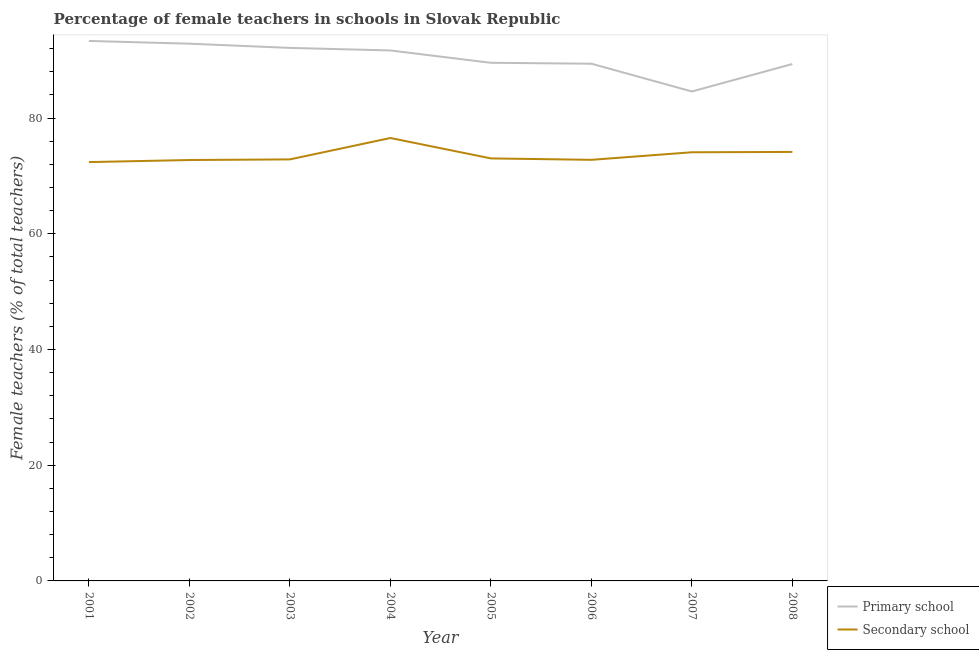Is the number of lines equal to the number of legend labels?
Keep it short and to the point. Yes. What is the percentage of female teachers in primary schools in 2007?
Your response must be concise. 84.6. Across all years, what is the maximum percentage of female teachers in primary schools?
Your response must be concise. 93.33. Across all years, what is the minimum percentage of female teachers in secondary schools?
Make the answer very short. 72.39. In which year was the percentage of female teachers in secondary schools maximum?
Give a very brief answer. 2004. What is the total percentage of female teachers in secondary schools in the graph?
Your response must be concise. 588.6. What is the difference between the percentage of female teachers in primary schools in 2004 and that in 2008?
Give a very brief answer. 2.34. What is the difference between the percentage of female teachers in secondary schools in 2002 and the percentage of female teachers in primary schools in 2003?
Provide a short and direct response. -19.38. What is the average percentage of female teachers in primary schools per year?
Ensure brevity in your answer.  90.36. In the year 2006, what is the difference between the percentage of female teachers in secondary schools and percentage of female teachers in primary schools?
Your answer should be compact. -16.61. What is the ratio of the percentage of female teachers in primary schools in 2007 to that in 2008?
Provide a succinct answer. 0.95. Is the percentage of female teachers in secondary schools in 2005 less than that in 2007?
Ensure brevity in your answer.  Yes. What is the difference between the highest and the second highest percentage of female teachers in primary schools?
Make the answer very short. 0.48. What is the difference between the highest and the lowest percentage of female teachers in primary schools?
Your response must be concise. 8.74. Is the sum of the percentage of female teachers in secondary schools in 2006 and 2007 greater than the maximum percentage of female teachers in primary schools across all years?
Offer a terse response. Yes. Does the percentage of female teachers in secondary schools monotonically increase over the years?
Give a very brief answer. No. Is the percentage of female teachers in secondary schools strictly greater than the percentage of female teachers in primary schools over the years?
Provide a short and direct response. No. How many lines are there?
Keep it short and to the point. 2. What is the difference between two consecutive major ticks on the Y-axis?
Offer a terse response. 20. Does the graph contain any zero values?
Provide a succinct answer. No. Where does the legend appear in the graph?
Offer a very short reply. Bottom right. How many legend labels are there?
Your answer should be compact. 2. What is the title of the graph?
Ensure brevity in your answer.  Percentage of female teachers in schools in Slovak Republic. Does "IMF nonconcessional" appear as one of the legend labels in the graph?
Your response must be concise. No. What is the label or title of the X-axis?
Keep it short and to the point. Year. What is the label or title of the Y-axis?
Ensure brevity in your answer.  Female teachers (% of total teachers). What is the Female teachers (% of total teachers) in Primary school in 2001?
Give a very brief answer. 93.33. What is the Female teachers (% of total teachers) of Secondary school in 2001?
Offer a very short reply. 72.39. What is the Female teachers (% of total teachers) in Primary school in 2002?
Your answer should be very brief. 92.85. What is the Female teachers (% of total teachers) of Secondary school in 2002?
Your answer should be compact. 72.75. What is the Female teachers (% of total teachers) in Primary school in 2003?
Ensure brevity in your answer.  92.13. What is the Female teachers (% of total teachers) of Secondary school in 2003?
Give a very brief answer. 72.86. What is the Female teachers (% of total teachers) of Primary school in 2004?
Provide a succinct answer. 91.69. What is the Female teachers (% of total teachers) of Secondary school in 2004?
Your answer should be compact. 76.55. What is the Female teachers (% of total teachers) in Primary school in 2005?
Provide a short and direct response. 89.55. What is the Female teachers (% of total teachers) of Secondary school in 2005?
Offer a terse response. 73.03. What is the Female teachers (% of total teachers) of Primary school in 2006?
Your response must be concise. 89.4. What is the Female teachers (% of total teachers) in Secondary school in 2006?
Ensure brevity in your answer.  72.78. What is the Female teachers (% of total teachers) of Primary school in 2007?
Provide a short and direct response. 84.6. What is the Female teachers (% of total teachers) of Secondary school in 2007?
Give a very brief answer. 74.09. What is the Female teachers (% of total teachers) of Primary school in 2008?
Offer a terse response. 89.34. What is the Female teachers (% of total teachers) in Secondary school in 2008?
Give a very brief answer. 74.15. Across all years, what is the maximum Female teachers (% of total teachers) in Primary school?
Offer a very short reply. 93.33. Across all years, what is the maximum Female teachers (% of total teachers) of Secondary school?
Provide a short and direct response. 76.55. Across all years, what is the minimum Female teachers (% of total teachers) in Primary school?
Provide a short and direct response. 84.6. Across all years, what is the minimum Female teachers (% of total teachers) of Secondary school?
Provide a short and direct response. 72.39. What is the total Female teachers (% of total teachers) in Primary school in the graph?
Ensure brevity in your answer.  722.88. What is the total Female teachers (% of total teachers) in Secondary school in the graph?
Provide a succinct answer. 588.6. What is the difference between the Female teachers (% of total teachers) of Primary school in 2001 and that in 2002?
Offer a very short reply. 0.48. What is the difference between the Female teachers (% of total teachers) in Secondary school in 2001 and that in 2002?
Ensure brevity in your answer.  -0.36. What is the difference between the Female teachers (% of total teachers) in Primary school in 2001 and that in 2003?
Your answer should be compact. 1.21. What is the difference between the Female teachers (% of total teachers) of Secondary school in 2001 and that in 2003?
Keep it short and to the point. -0.47. What is the difference between the Female teachers (% of total teachers) of Primary school in 2001 and that in 2004?
Offer a very short reply. 1.65. What is the difference between the Female teachers (% of total teachers) of Secondary school in 2001 and that in 2004?
Offer a very short reply. -4.16. What is the difference between the Female teachers (% of total teachers) in Primary school in 2001 and that in 2005?
Keep it short and to the point. 3.78. What is the difference between the Female teachers (% of total teachers) of Secondary school in 2001 and that in 2005?
Your response must be concise. -0.64. What is the difference between the Female teachers (% of total teachers) in Primary school in 2001 and that in 2006?
Provide a short and direct response. 3.93. What is the difference between the Female teachers (% of total teachers) of Secondary school in 2001 and that in 2006?
Ensure brevity in your answer.  -0.39. What is the difference between the Female teachers (% of total teachers) of Primary school in 2001 and that in 2007?
Keep it short and to the point. 8.74. What is the difference between the Female teachers (% of total teachers) in Secondary school in 2001 and that in 2007?
Keep it short and to the point. -1.7. What is the difference between the Female teachers (% of total teachers) of Primary school in 2001 and that in 2008?
Offer a terse response. 3.99. What is the difference between the Female teachers (% of total teachers) in Secondary school in 2001 and that in 2008?
Give a very brief answer. -1.76. What is the difference between the Female teachers (% of total teachers) of Primary school in 2002 and that in 2003?
Ensure brevity in your answer.  0.73. What is the difference between the Female teachers (% of total teachers) in Secondary school in 2002 and that in 2003?
Provide a succinct answer. -0.11. What is the difference between the Female teachers (% of total teachers) of Primary school in 2002 and that in 2004?
Provide a succinct answer. 1.17. What is the difference between the Female teachers (% of total teachers) of Secondary school in 2002 and that in 2004?
Your answer should be very brief. -3.8. What is the difference between the Female teachers (% of total teachers) in Primary school in 2002 and that in 2005?
Keep it short and to the point. 3.3. What is the difference between the Female teachers (% of total teachers) in Secondary school in 2002 and that in 2005?
Give a very brief answer. -0.28. What is the difference between the Female teachers (% of total teachers) in Primary school in 2002 and that in 2006?
Make the answer very short. 3.46. What is the difference between the Female teachers (% of total teachers) of Secondary school in 2002 and that in 2006?
Provide a short and direct response. -0.03. What is the difference between the Female teachers (% of total teachers) in Primary school in 2002 and that in 2007?
Give a very brief answer. 8.26. What is the difference between the Female teachers (% of total teachers) in Secondary school in 2002 and that in 2007?
Offer a terse response. -1.34. What is the difference between the Female teachers (% of total teachers) in Primary school in 2002 and that in 2008?
Ensure brevity in your answer.  3.51. What is the difference between the Female teachers (% of total teachers) of Secondary school in 2002 and that in 2008?
Offer a very short reply. -1.4. What is the difference between the Female teachers (% of total teachers) in Primary school in 2003 and that in 2004?
Your answer should be compact. 0.44. What is the difference between the Female teachers (% of total teachers) of Secondary school in 2003 and that in 2004?
Make the answer very short. -3.7. What is the difference between the Female teachers (% of total teachers) of Primary school in 2003 and that in 2005?
Your answer should be very brief. 2.57. What is the difference between the Female teachers (% of total teachers) in Secondary school in 2003 and that in 2005?
Offer a very short reply. -0.17. What is the difference between the Female teachers (% of total teachers) of Primary school in 2003 and that in 2006?
Provide a short and direct response. 2.73. What is the difference between the Female teachers (% of total teachers) of Secondary school in 2003 and that in 2006?
Provide a short and direct response. 0.07. What is the difference between the Female teachers (% of total teachers) in Primary school in 2003 and that in 2007?
Keep it short and to the point. 7.53. What is the difference between the Female teachers (% of total teachers) of Secondary school in 2003 and that in 2007?
Offer a terse response. -1.23. What is the difference between the Female teachers (% of total teachers) in Primary school in 2003 and that in 2008?
Offer a very short reply. 2.78. What is the difference between the Female teachers (% of total teachers) of Secondary school in 2003 and that in 2008?
Make the answer very short. -1.29. What is the difference between the Female teachers (% of total teachers) of Primary school in 2004 and that in 2005?
Keep it short and to the point. 2.13. What is the difference between the Female teachers (% of total teachers) in Secondary school in 2004 and that in 2005?
Provide a succinct answer. 3.53. What is the difference between the Female teachers (% of total teachers) of Primary school in 2004 and that in 2006?
Your response must be concise. 2.29. What is the difference between the Female teachers (% of total teachers) in Secondary school in 2004 and that in 2006?
Keep it short and to the point. 3.77. What is the difference between the Female teachers (% of total teachers) of Primary school in 2004 and that in 2007?
Give a very brief answer. 7.09. What is the difference between the Female teachers (% of total teachers) in Secondary school in 2004 and that in 2007?
Provide a short and direct response. 2.46. What is the difference between the Female teachers (% of total teachers) in Primary school in 2004 and that in 2008?
Your answer should be very brief. 2.34. What is the difference between the Female teachers (% of total teachers) in Secondary school in 2004 and that in 2008?
Offer a terse response. 2.41. What is the difference between the Female teachers (% of total teachers) of Primary school in 2005 and that in 2006?
Give a very brief answer. 0.16. What is the difference between the Female teachers (% of total teachers) in Secondary school in 2005 and that in 2006?
Keep it short and to the point. 0.25. What is the difference between the Female teachers (% of total teachers) of Primary school in 2005 and that in 2007?
Provide a succinct answer. 4.96. What is the difference between the Female teachers (% of total teachers) in Secondary school in 2005 and that in 2007?
Provide a short and direct response. -1.06. What is the difference between the Female teachers (% of total teachers) of Primary school in 2005 and that in 2008?
Offer a terse response. 0.21. What is the difference between the Female teachers (% of total teachers) in Secondary school in 2005 and that in 2008?
Give a very brief answer. -1.12. What is the difference between the Female teachers (% of total teachers) of Primary school in 2006 and that in 2007?
Provide a short and direct response. 4.8. What is the difference between the Female teachers (% of total teachers) in Secondary school in 2006 and that in 2007?
Provide a short and direct response. -1.31. What is the difference between the Female teachers (% of total teachers) of Primary school in 2006 and that in 2008?
Your answer should be compact. 0.06. What is the difference between the Female teachers (% of total teachers) in Secondary school in 2006 and that in 2008?
Offer a very short reply. -1.37. What is the difference between the Female teachers (% of total teachers) in Primary school in 2007 and that in 2008?
Give a very brief answer. -4.75. What is the difference between the Female teachers (% of total teachers) in Secondary school in 2007 and that in 2008?
Offer a very short reply. -0.06. What is the difference between the Female teachers (% of total teachers) in Primary school in 2001 and the Female teachers (% of total teachers) in Secondary school in 2002?
Offer a terse response. 20.58. What is the difference between the Female teachers (% of total teachers) in Primary school in 2001 and the Female teachers (% of total teachers) in Secondary school in 2003?
Ensure brevity in your answer.  20.47. What is the difference between the Female teachers (% of total teachers) in Primary school in 2001 and the Female teachers (% of total teachers) in Secondary school in 2004?
Keep it short and to the point. 16.78. What is the difference between the Female teachers (% of total teachers) of Primary school in 2001 and the Female teachers (% of total teachers) of Secondary school in 2005?
Your answer should be very brief. 20.3. What is the difference between the Female teachers (% of total teachers) in Primary school in 2001 and the Female teachers (% of total teachers) in Secondary school in 2006?
Your answer should be very brief. 20.55. What is the difference between the Female teachers (% of total teachers) of Primary school in 2001 and the Female teachers (% of total teachers) of Secondary school in 2007?
Make the answer very short. 19.24. What is the difference between the Female teachers (% of total teachers) in Primary school in 2001 and the Female teachers (% of total teachers) in Secondary school in 2008?
Offer a terse response. 19.18. What is the difference between the Female teachers (% of total teachers) in Primary school in 2002 and the Female teachers (% of total teachers) in Secondary school in 2003?
Offer a very short reply. 20. What is the difference between the Female teachers (% of total teachers) of Primary school in 2002 and the Female teachers (% of total teachers) of Secondary school in 2004?
Provide a succinct answer. 16.3. What is the difference between the Female teachers (% of total teachers) in Primary school in 2002 and the Female teachers (% of total teachers) in Secondary school in 2005?
Provide a short and direct response. 19.83. What is the difference between the Female teachers (% of total teachers) in Primary school in 2002 and the Female teachers (% of total teachers) in Secondary school in 2006?
Your answer should be compact. 20.07. What is the difference between the Female teachers (% of total teachers) of Primary school in 2002 and the Female teachers (% of total teachers) of Secondary school in 2007?
Make the answer very short. 18.77. What is the difference between the Female teachers (% of total teachers) in Primary school in 2002 and the Female teachers (% of total teachers) in Secondary school in 2008?
Provide a short and direct response. 18.71. What is the difference between the Female teachers (% of total teachers) in Primary school in 2003 and the Female teachers (% of total teachers) in Secondary school in 2004?
Keep it short and to the point. 15.57. What is the difference between the Female teachers (% of total teachers) of Primary school in 2003 and the Female teachers (% of total teachers) of Secondary school in 2005?
Ensure brevity in your answer.  19.1. What is the difference between the Female teachers (% of total teachers) in Primary school in 2003 and the Female teachers (% of total teachers) in Secondary school in 2006?
Your answer should be very brief. 19.34. What is the difference between the Female teachers (% of total teachers) in Primary school in 2003 and the Female teachers (% of total teachers) in Secondary school in 2007?
Ensure brevity in your answer.  18.04. What is the difference between the Female teachers (% of total teachers) of Primary school in 2003 and the Female teachers (% of total teachers) of Secondary school in 2008?
Offer a very short reply. 17.98. What is the difference between the Female teachers (% of total teachers) in Primary school in 2004 and the Female teachers (% of total teachers) in Secondary school in 2005?
Give a very brief answer. 18.66. What is the difference between the Female teachers (% of total teachers) of Primary school in 2004 and the Female teachers (% of total teachers) of Secondary school in 2006?
Your answer should be compact. 18.9. What is the difference between the Female teachers (% of total teachers) in Primary school in 2004 and the Female teachers (% of total teachers) in Secondary school in 2007?
Give a very brief answer. 17.6. What is the difference between the Female teachers (% of total teachers) of Primary school in 2004 and the Female teachers (% of total teachers) of Secondary school in 2008?
Your answer should be very brief. 17.54. What is the difference between the Female teachers (% of total teachers) in Primary school in 2005 and the Female teachers (% of total teachers) in Secondary school in 2006?
Provide a succinct answer. 16.77. What is the difference between the Female teachers (% of total teachers) of Primary school in 2005 and the Female teachers (% of total teachers) of Secondary school in 2007?
Offer a terse response. 15.46. What is the difference between the Female teachers (% of total teachers) in Primary school in 2005 and the Female teachers (% of total teachers) in Secondary school in 2008?
Offer a terse response. 15.4. What is the difference between the Female teachers (% of total teachers) of Primary school in 2006 and the Female teachers (% of total teachers) of Secondary school in 2007?
Keep it short and to the point. 15.31. What is the difference between the Female teachers (% of total teachers) of Primary school in 2006 and the Female teachers (% of total teachers) of Secondary school in 2008?
Provide a succinct answer. 15.25. What is the difference between the Female teachers (% of total teachers) of Primary school in 2007 and the Female teachers (% of total teachers) of Secondary school in 2008?
Your answer should be very brief. 10.45. What is the average Female teachers (% of total teachers) of Primary school per year?
Ensure brevity in your answer.  90.36. What is the average Female teachers (% of total teachers) of Secondary school per year?
Your answer should be very brief. 73.57. In the year 2001, what is the difference between the Female teachers (% of total teachers) in Primary school and Female teachers (% of total teachers) in Secondary school?
Your answer should be compact. 20.94. In the year 2002, what is the difference between the Female teachers (% of total teachers) of Primary school and Female teachers (% of total teachers) of Secondary school?
Your answer should be very brief. 20.11. In the year 2003, what is the difference between the Female teachers (% of total teachers) of Primary school and Female teachers (% of total teachers) of Secondary school?
Keep it short and to the point. 19.27. In the year 2004, what is the difference between the Female teachers (% of total teachers) of Primary school and Female teachers (% of total teachers) of Secondary school?
Your response must be concise. 15.13. In the year 2005, what is the difference between the Female teachers (% of total teachers) of Primary school and Female teachers (% of total teachers) of Secondary school?
Your answer should be very brief. 16.52. In the year 2006, what is the difference between the Female teachers (% of total teachers) in Primary school and Female teachers (% of total teachers) in Secondary school?
Offer a terse response. 16.61. In the year 2007, what is the difference between the Female teachers (% of total teachers) of Primary school and Female teachers (% of total teachers) of Secondary school?
Offer a terse response. 10.51. In the year 2008, what is the difference between the Female teachers (% of total teachers) of Primary school and Female teachers (% of total teachers) of Secondary school?
Your response must be concise. 15.19. What is the ratio of the Female teachers (% of total teachers) of Primary school in 2001 to that in 2002?
Provide a succinct answer. 1.01. What is the ratio of the Female teachers (% of total teachers) in Primary school in 2001 to that in 2003?
Ensure brevity in your answer.  1.01. What is the ratio of the Female teachers (% of total teachers) in Primary school in 2001 to that in 2004?
Make the answer very short. 1.02. What is the ratio of the Female teachers (% of total teachers) of Secondary school in 2001 to that in 2004?
Your response must be concise. 0.95. What is the ratio of the Female teachers (% of total teachers) of Primary school in 2001 to that in 2005?
Offer a terse response. 1.04. What is the ratio of the Female teachers (% of total teachers) of Secondary school in 2001 to that in 2005?
Offer a very short reply. 0.99. What is the ratio of the Female teachers (% of total teachers) in Primary school in 2001 to that in 2006?
Your answer should be compact. 1.04. What is the ratio of the Female teachers (% of total teachers) of Primary school in 2001 to that in 2007?
Provide a short and direct response. 1.1. What is the ratio of the Female teachers (% of total teachers) in Secondary school in 2001 to that in 2007?
Make the answer very short. 0.98. What is the ratio of the Female teachers (% of total teachers) in Primary school in 2001 to that in 2008?
Offer a very short reply. 1.04. What is the ratio of the Female teachers (% of total teachers) of Secondary school in 2001 to that in 2008?
Offer a terse response. 0.98. What is the ratio of the Female teachers (% of total teachers) in Primary school in 2002 to that in 2003?
Ensure brevity in your answer.  1.01. What is the ratio of the Female teachers (% of total teachers) in Primary school in 2002 to that in 2004?
Offer a very short reply. 1.01. What is the ratio of the Female teachers (% of total teachers) in Secondary school in 2002 to that in 2004?
Provide a short and direct response. 0.95. What is the ratio of the Female teachers (% of total teachers) of Primary school in 2002 to that in 2005?
Your response must be concise. 1.04. What is the ratio of the Female teachers (% of total teachers) of Primary school in 2002 to that in 2006?
Offer a terse response. 1.04. What is the ratio of the Female teachers (% of total teachers) in Secondary school in 2002 to that in 2006?
Keep it short and to the point. 1. What is the ratio of the Female teachers (% of total teachers) of Primary school in 2002 to that in 2007?
Your answer should be very brief. 1.1. What is the ratio of the Female teachers (% of total teachers) in Secondary school in 2002 to that in 2007?
Your answer should be compact. 0.98. What is the ratio of the Female teachers (% of total teachers) of Primary school in 2002 to that in 2008?
Make the answer very short. 1.04. What is the ratio of the Female teachers (% of total teachers) of Secondary school in 2002 to that in 2008?
Make the answer very short. 0.98. What is the ratio of the Female teachers (% of total teachers) of Primary school in 2003 to that in 2004?
Offer a very short reply. 1. What is the ratio of the Female teachers (% of total teachers) in Secondary school in 2003 to that in 2004?
Offer a very short reply. 0.95. What is the ratio of the Female teachers (% of total teachers) in Primary school in 2003 to that in 2005?
Your answer should be compact. 1.03. What is the ratio of the Female teachers (% of total teachers) in Primary school in 2003 to that in 2006?
Your answer should be compact. 1.03. What is the ratio of the Female teachers (% of total teachers) of Secondary school in 2003 to that in 2006?
Keep it short and to the point. 1. What is the ratio of the Female teachers (% of total teachers) of Primary school in 2003 to that in 2007?
Make the answer very short. 1.09. What is the ratio of the Female teachers (% of total teachers) in Secondary school in 2003 to that in 2007?
Ensure brevity in your answer.  0.98. What is the ratio of the Female teachers (% of total teachers) in Primary school in 2003 to that in 2008?
Keep it short and to the point. 1.03. What is the ratio of the Female teachers (% of total teachers) in Secondary school in 2003 to that in 2008?
Provide a succinct answer. 0.98. What is the ratio of the Female teachers (% of total teachers) of Primary school in 2004 to that in 2005?
Keep it short and to the point. 1.02. What is the ratio of the Female teachers (% of total teachers) in Secondary school in 2004 to that in 2005?
Offer a very short reply. 1.05. What is the ratio of the Female teachers (% of total teachers) in Primary school in 2004 to that in 2006?
Keep it short and to the point. 1.03. What is the ratio of the Female teachers (% of total teachers) in Secondary school in 2004 to that in 2006?
Your answer should be compact. 1.05. What is the ratio of the Female teachers (% of total teachers) in Primary school in 2004 to that in 2007?
Your answer should be very brief. 1.08. What is the ratio of the Female teachers (% of total teachers) of Secondary school in 2004 to that in 2007?
Give a very brief answer. 1.03. What is the ratio of the Female teachers (% of total teachers) in Primary school in 2004 to that in 2008?
Offer a very short reply. 1.03. What is the ratio of the Female teachers (% of total teachers) in Secondary school in 2004 to that in 2008?
Offer a terse response. 1.03. What is the ratio of the Female teachers (% of total teachers) in Primary school in 2005 to that in 2006?
Your answer should be very brief. 1. What is the ratio of the Female teachers (% of total teachers) of Primary school in 2005 to that in 2007?
Ensure brevity in your answer.  1.06. What is the ratio of the Female teachers (% of total teachers) of Secondary school in 2005 to that in 2007?
Ensure brevity in your answer.  0.99. What is the ratio of the Female teachers (% of total teachers) of Primary school in 2005 to that in 2008?
Give a very brief answer. 1. What is the ratio of the Female teachers (% of total teachers) of Secondary school in 2005 to that in 2008?
Provide a short and direct response. 0.98. What is the ratio of the Female teachers (% of total teachers) of Primary school in 2006 to that in 2007?
Your answer should be very brief. 1.06. What is the ratio of the Female teachers (% of total teachers) in Secondary school in 2006 to that in 2007?
Provide a succinct answer. 0.98. What is the ratio of the Female teachers (% of total teachers) in Primary school in 2006 to that in 2008?
Your answer should be very brief. 1. What is the ratio of the Female teachers (% of total teachers) of Secondary school in 2006 to that in 2008?
Provide a succinct answer. 0.98. What is the ratio of the Female teachers (% of total teachers) of Primary school in 2007 to that in 2008?
Make the answer very short. 0.95. What is the difference between the highest and the second highest Female teachers (% of total teachers) of Primary school?
Offer a terse response. 0.48. What is the difference between the highest and the second highest Female teachers (% of total teachers) in Secondary school?
Your response must be concise. 2.41. What is the difference between the highest and the lowest Female teachers (% of total teachers) of Primary school?
Provide a short and direct response. 8.74. What is the difference between the highest and the lowest Female teachers (% of total teachers) in Secondary school?
Provide a succinct answer. 4.16. 